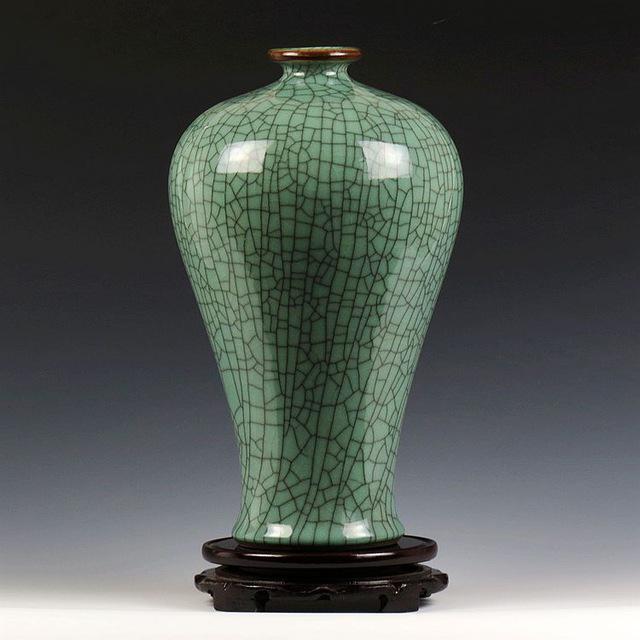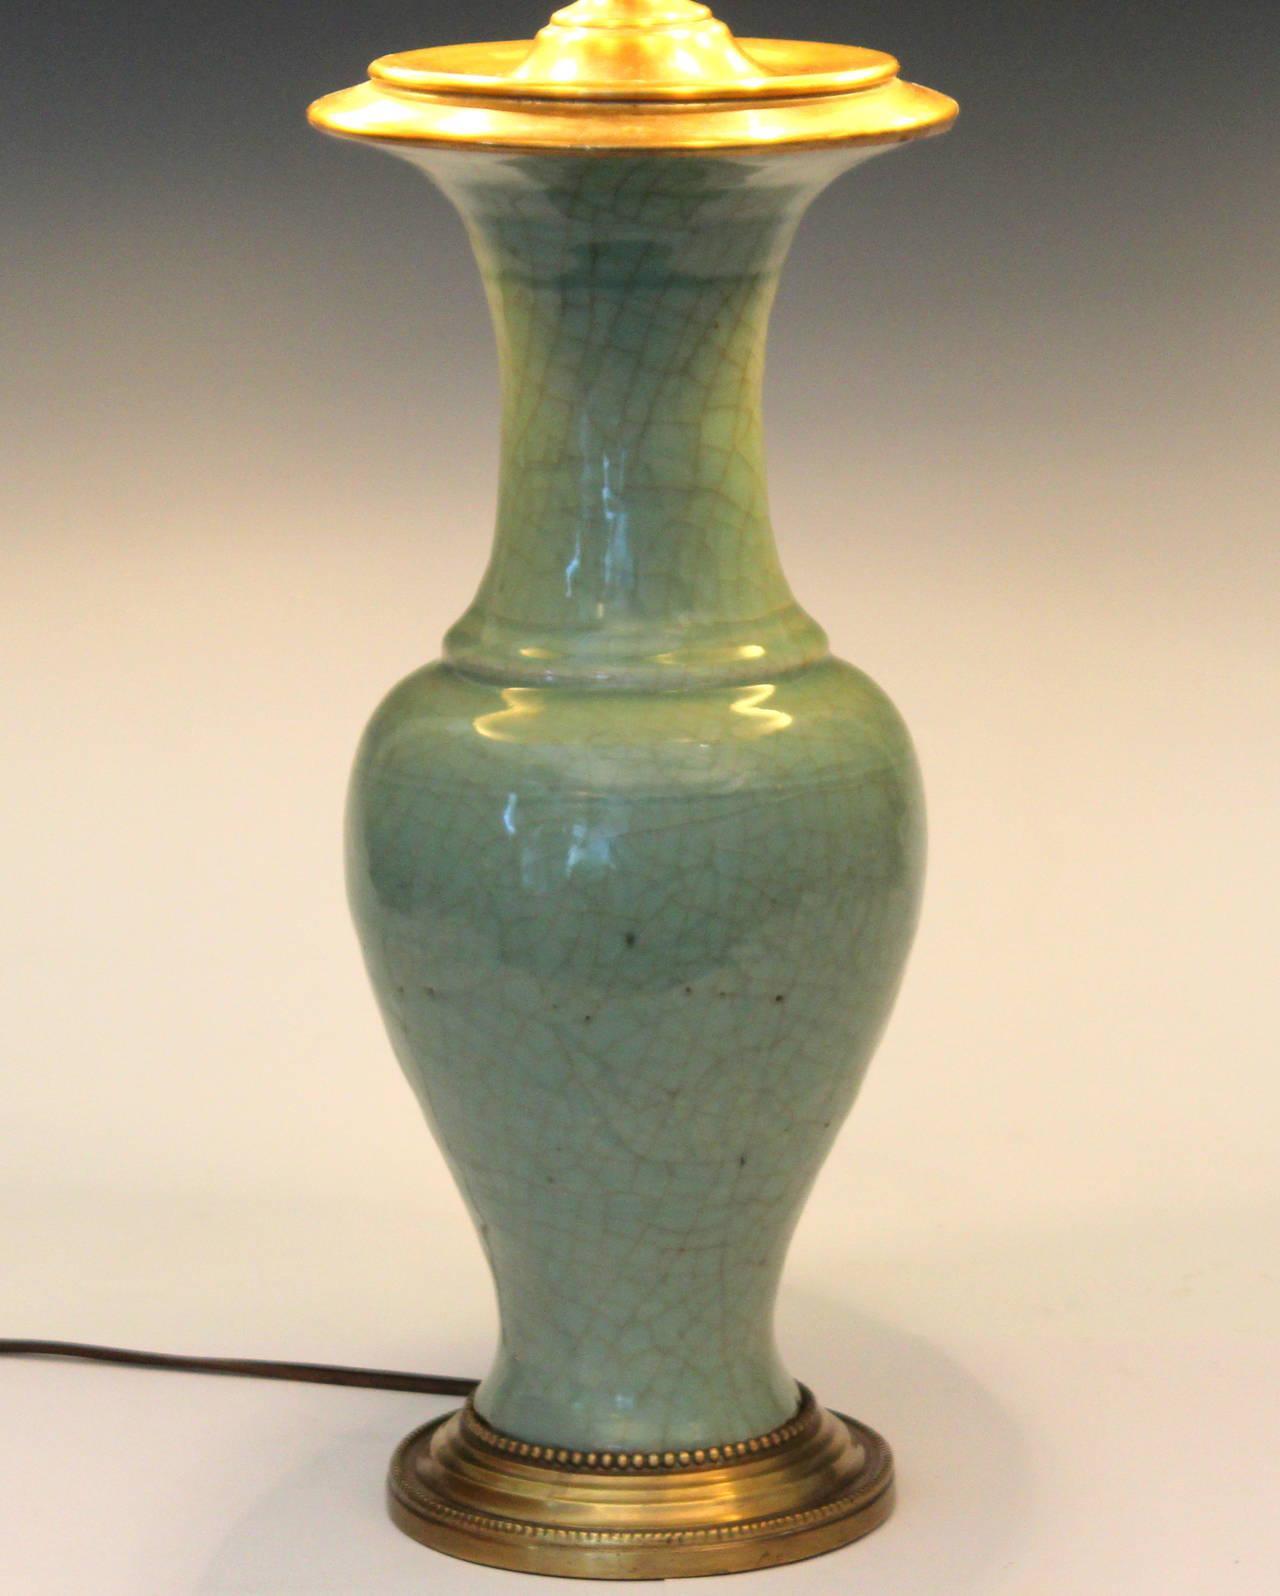The first image is the image on the left, the second image is the image on the right. Analyze the images presented: Is the assertion "At least one of the lamps shown features a shiny brass base." valid? Answer yes or no. Yes. The first image is the image on the left, the second image is the image on the right. Assess this claim about the two images: "All ceramic objects are jade green, and at least one has a crackle finish, and at least one flares out at the top.". Correct or not? Answer yes or no. Yes. 